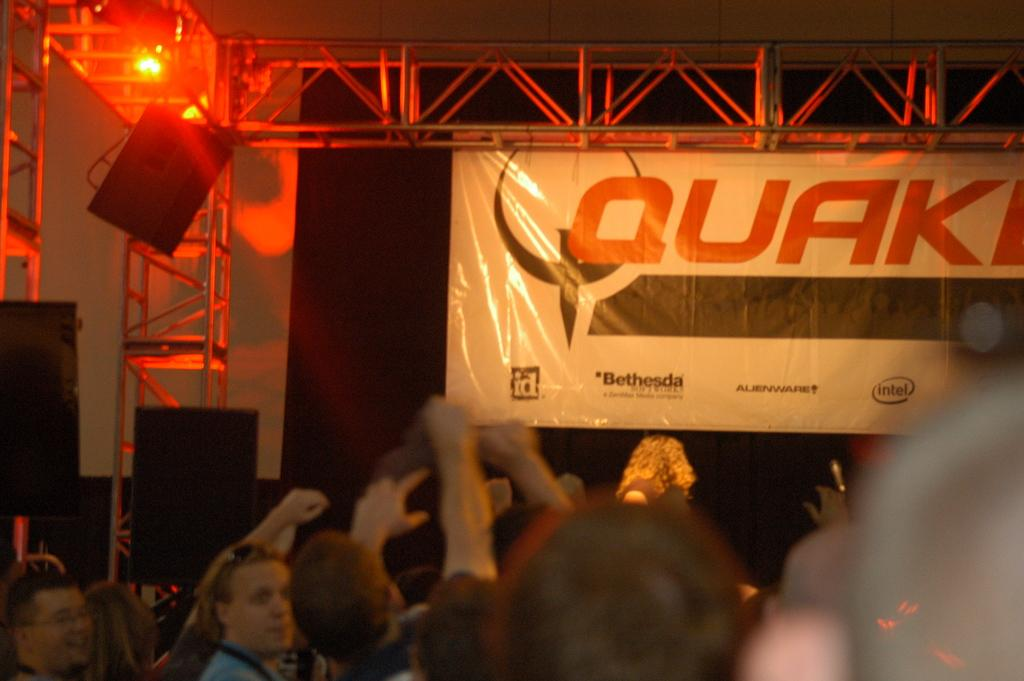Who or what is present in the image? There are people in the image. What can be seen in the background of the image? In the background of the image, there are rods, lights, and a banner. What is written on the banner? There is text written on the banner. How many dogs are visible in the image? There are no dogs present in the image. What type of sponge is being used by the people in the image? There is no sponge visible in the image. 